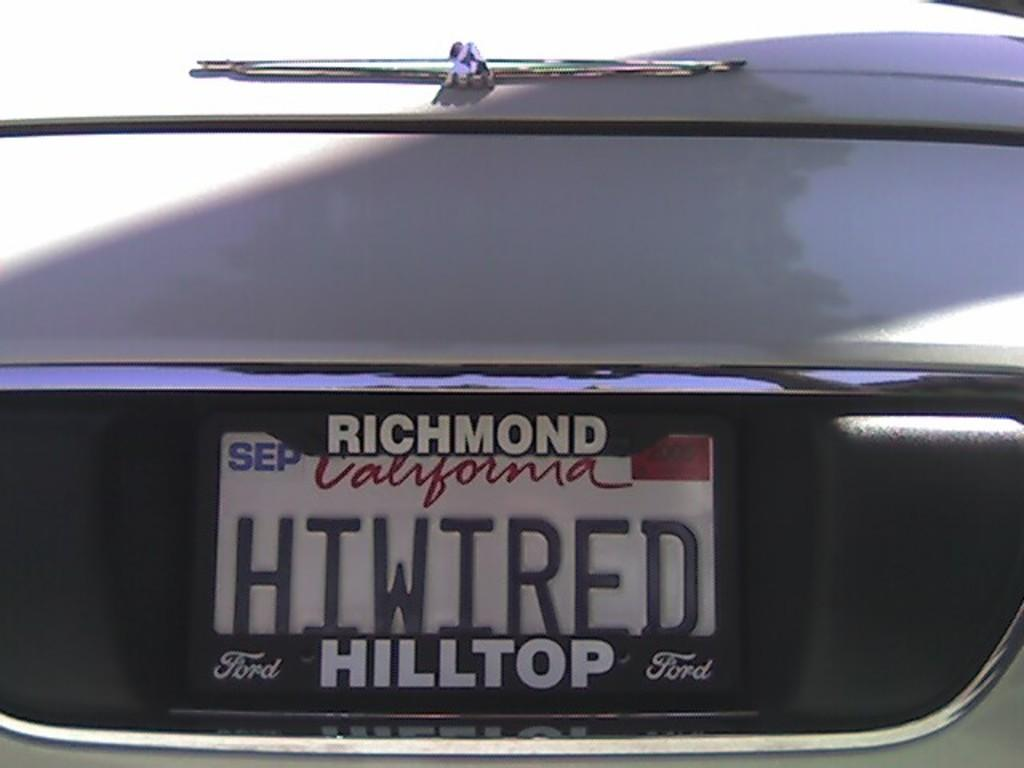<image>
Share a concise interpretation of the image provided. A license plate from California where they purchased their car from Hilltop Ford. 